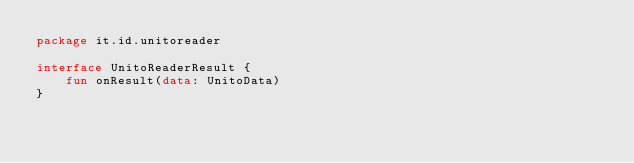Convert code to text. <code><loc_0><loc_0><loc_500><loc_500><_Kotlin_>package it.id.unitoreader

interface UnitoReaderResult {
    fun onResult(data: UnitoData)
}</code> 